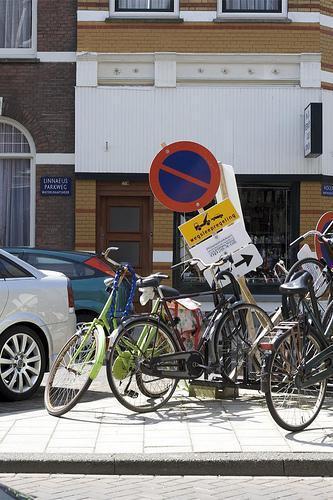How many different types of vehicles are here?
Give a very brief answer. 2. How many cars are there?
Give a very brief answer. 2. How many bicycles are visible?
Give a very brief answer. 3. 